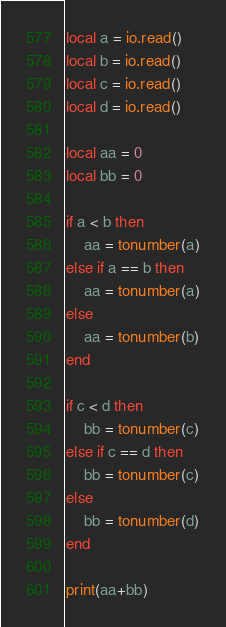Convert code to text. <code><loc_0><loc_0><loc_500><loc_500><_Lua_>local a = io.read()
local b = io.read()
local c = io.read()
local d = io.read()

local aa = 0 
local bb = 0 

if a < b then
    aa = tonumber(a)
else if a == b then
    aa = tonumber(a)
else
    aa = tonumber(b)
end

if c < d then
    bb = tonumber(c)
else if c == d then
    bb = tonumber(c)
else
    bb = tonumber(d)
end

print(aa+bb)</code> 